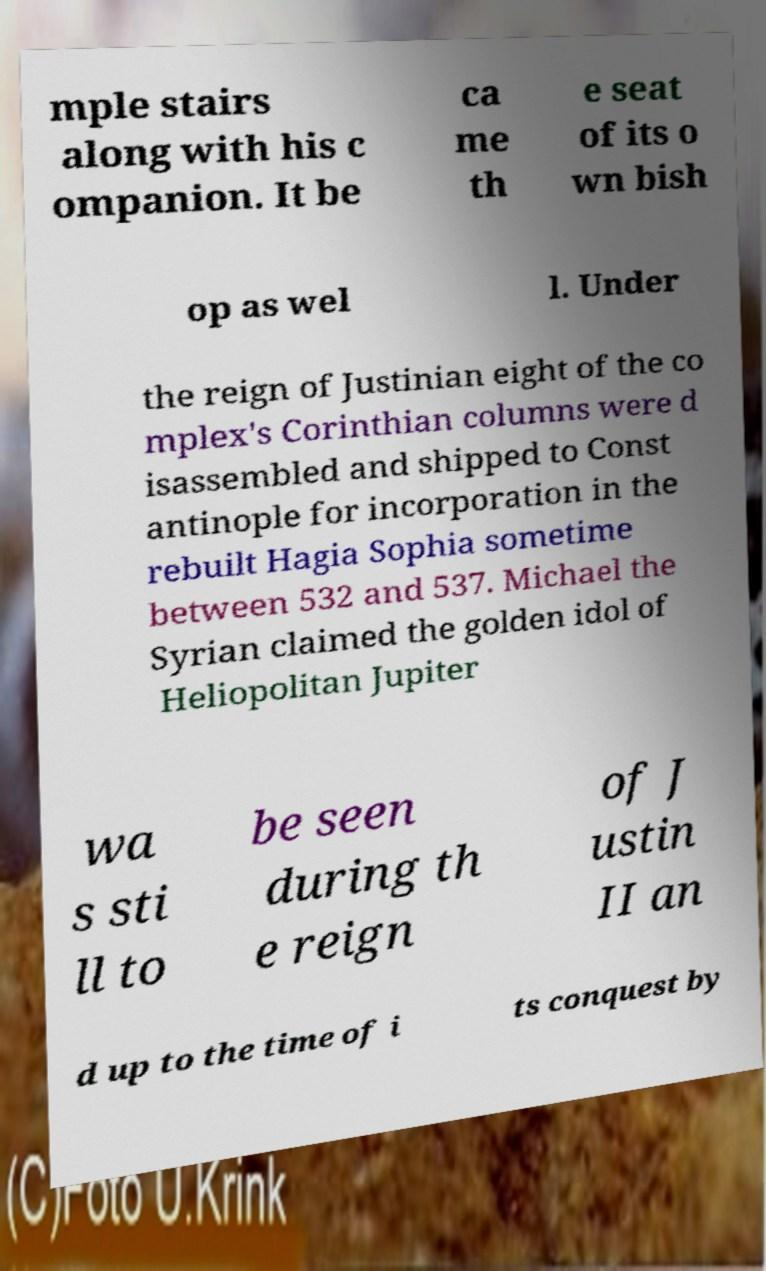Could you assist in decoding the text presented in this image and type it out clearly? mple stairs along with his c ompanion. It be ca me th e seat of its o wn bish op as wel l. Under the reign of Justinian eight of the co mplex's Corinthian columns were d isassembled and shipped to Const antinople for incorporation in the rebuilt Hagia Sophia sometime between 532 and 537. Michael the Syrian claimed the golden idol of Heliopolitan Jupiter wa s sti ll to be seen during th e reign of J ustin II an d up to the time of i ts conquest by 